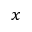<formula> <loc_0><loc_0><loc_500><loc_500>x</formula> 